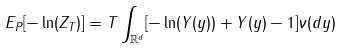Convert formula to latex. <formula><loc_0><loc_0><loc_500><loc_500>E _ { P } [ - \ln ( Z _ { T } ) ] = T \int _ { \mathbb { R } ^ { d } } [ - \ln ( Y ( y ) ) + Y ( y ) - 1 ] \nu ( d y )</formula> 